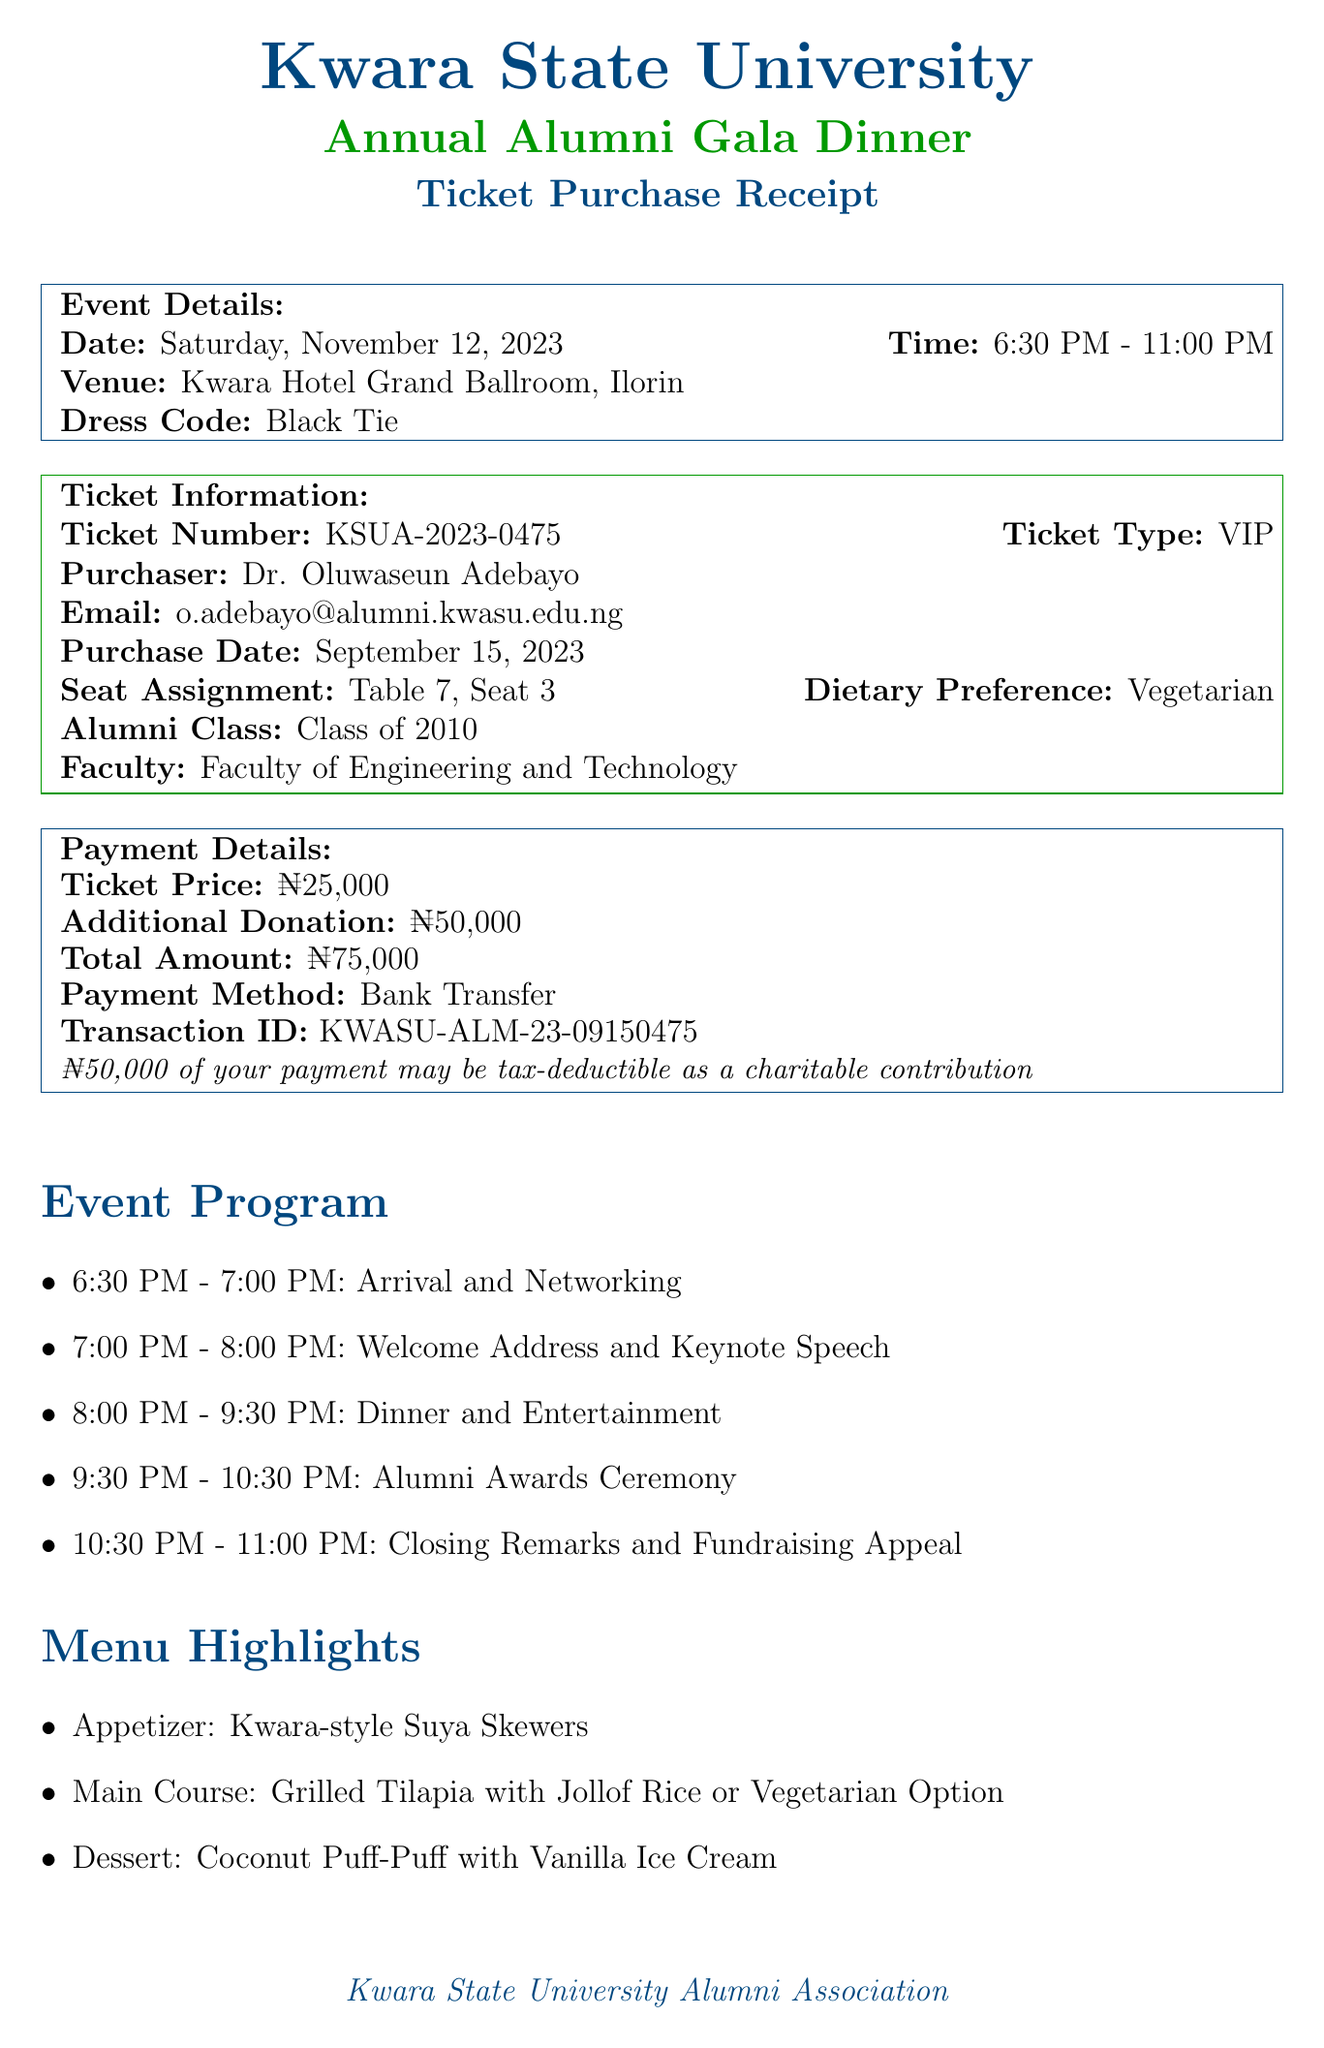What is the event name? The event name is stated clearly in the document, which lists the gala dinner organized by the alumni association.
Answer: Kwara State University Annual Alumni Gala Dinner What is the date of the event? The date is explicitly mentioned in the event details section of the document.
Answer: Saturday, November 12, 2023 Who is the purchaser of the ticket? The purchaser's name is provided in the ticket information section of the receipt.
Answer: Dr. Oluwaseun Adebayo What is the seat assignment? The seat assignment is included in the ticket information section of the receipt, specifying the exact table and seat number.
Answer: Table 7, Seat 3 What is the ticket price? The ticket price is listed in the payment details, indicating the cost of a VIP ticket.
Answer: ₦25,000 How much was the additional donation? Information regarding the additional donation by the purchaser is provided in the payment details section of the receipt.
Answer: ₦50,000 What is the fundraising goal? The total fundraising goal for the event is specified in the special notes section of the document.
Answer: ₦10,000,000 for KWASU Science Laboratory Upgrade What dietary preference was selected? The dietary preference is clearly mentioned in the ticket information, indicating the choice made by the purchaser.
Answer: Vegetarian What is the dress code for the event? The dress code is noted in the event details, giving guidelines on the expected attire for attendees.
Answer: Black Tie Who should be contacted for questions? The contact person for inquiries is provided in the special notes section of the receipt, indicating whom to reach out to.
Answer: Mrs. Aisha Ibrahim, Alumni Relations Officer 